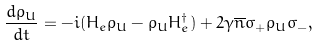Convert formula to latex. <formula><loc_0><loc_0><loc_500><loc_500>\frac { d \rho _ { U } } { d t } = - i ( H _ { e } \rho _ { U } - \rho _ { U } H _ { e } ^ { \dagger } ) + 2 \gamma \overline { n } \sigma _ { + } \rho _ { U } \sigma _ { - } ,</formula> 